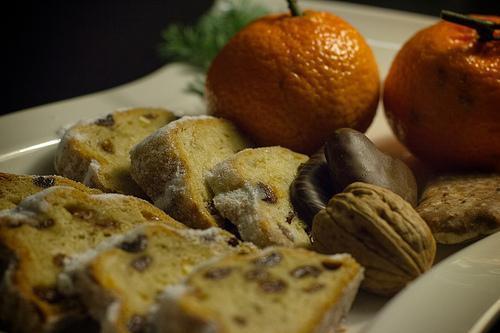How many oranges are in the image?
Give a very brief answer. 2. How many walnuts are on the plate?
Give a very brief answer. 1. 